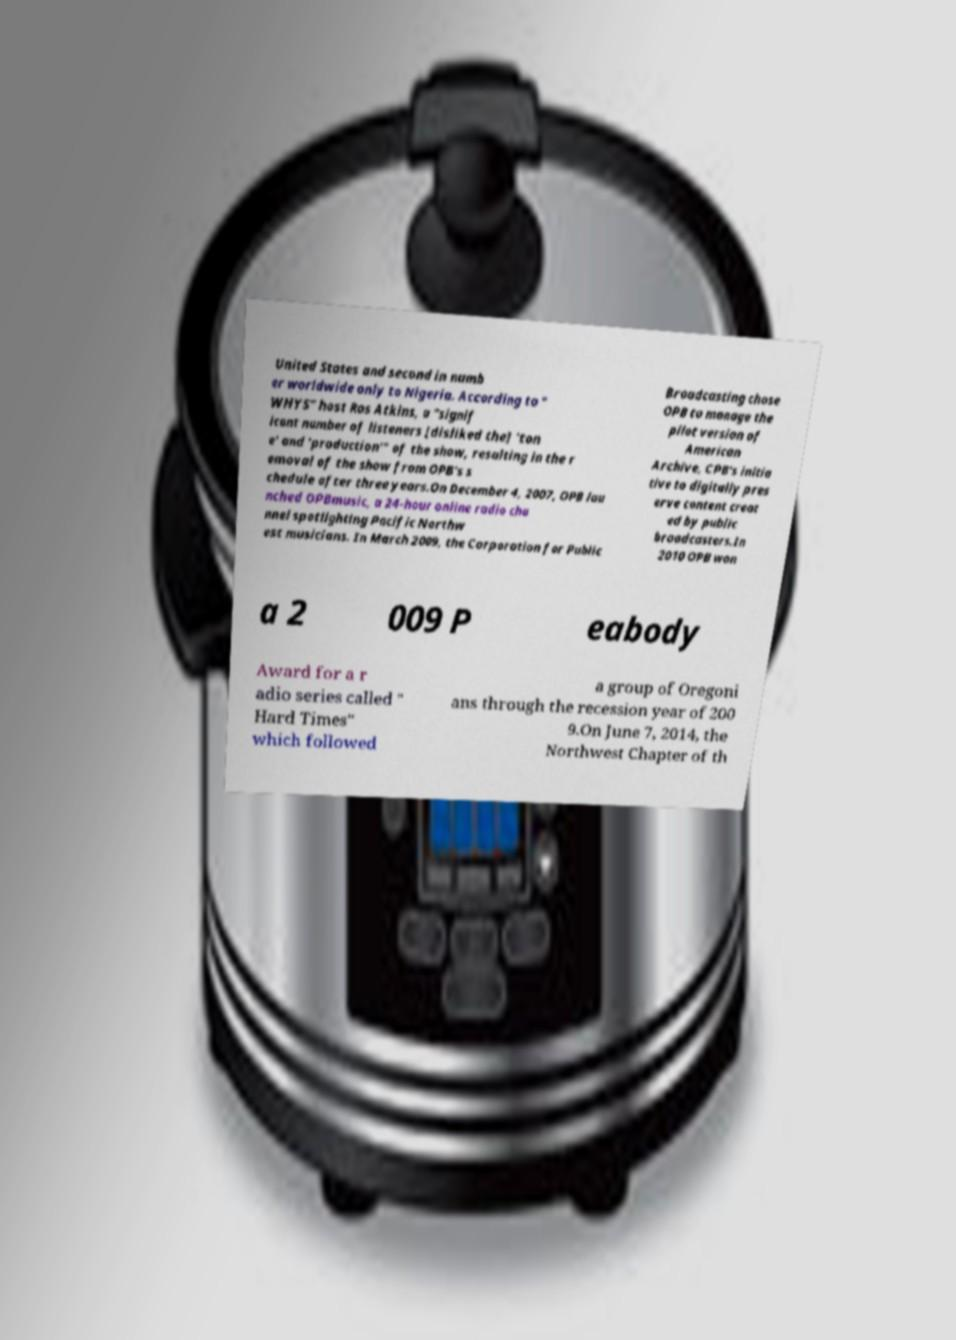Could you extract and type out the text from this image? United States and second in numb er worldwide only to Nigeria. According to " WHYS" host Ros Atkins, a "signif icant number of listeners [disliked the] 'ton e' and 'production'" of the show, resulting in the r emoval of the show from OPB's s chedule after three years.On December 4, 2007, OPB lau nched OPBmusic, a 24-hour online radio cha nnel spotlighting Pacific Northw est musicians. In March 2009, the Corporation for Public Broadcasting chose OPB to manage the pilot version of American Archive, CPB's initia tive to digitally pres erve content creat ed by public broadcasters.In 2010 OPB won a 2 009 P eabody Award for a r adio series called " Hard Times" which followed a group of Oregoni ans through the recession year of 200 9.On June 7, 2014, the Northwest Chapter of th 